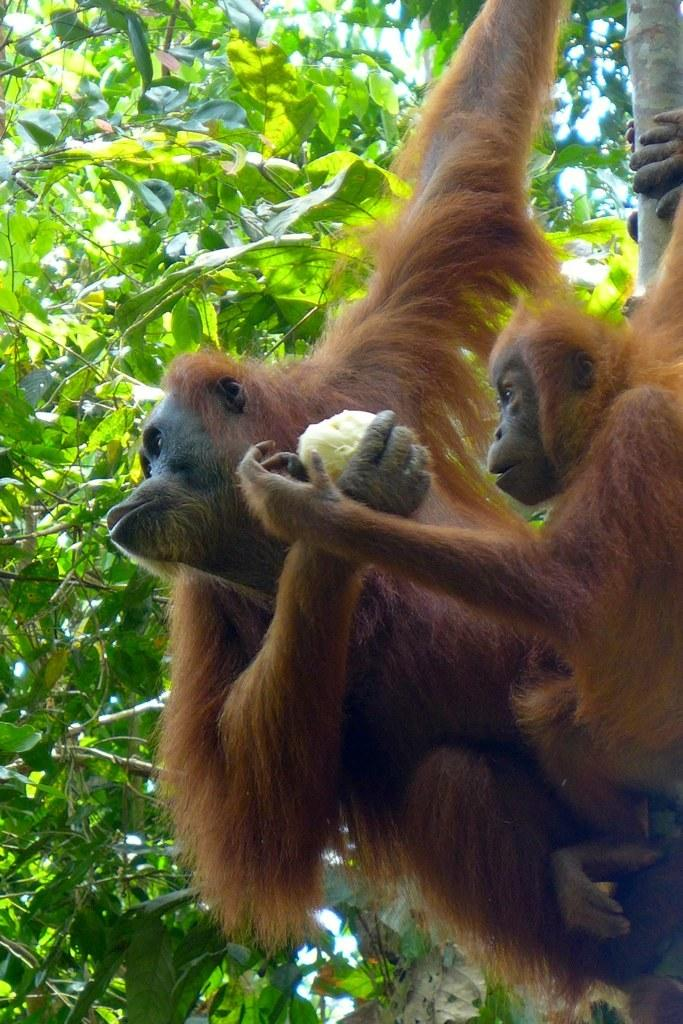How many monkeys are in the image? There are two brown monkeys in the image. What is one of the monkeys doing in the image? One of the monkeys is holding an object. What can be seen in the background of the image? There are green leaves in the background of the image. Are there any fairies visible in the image? No, there are no fairies present in the image. What is the value of the object being held by the monkey in the image? The value of the object cannot be determined from the image, as it is not specified. 